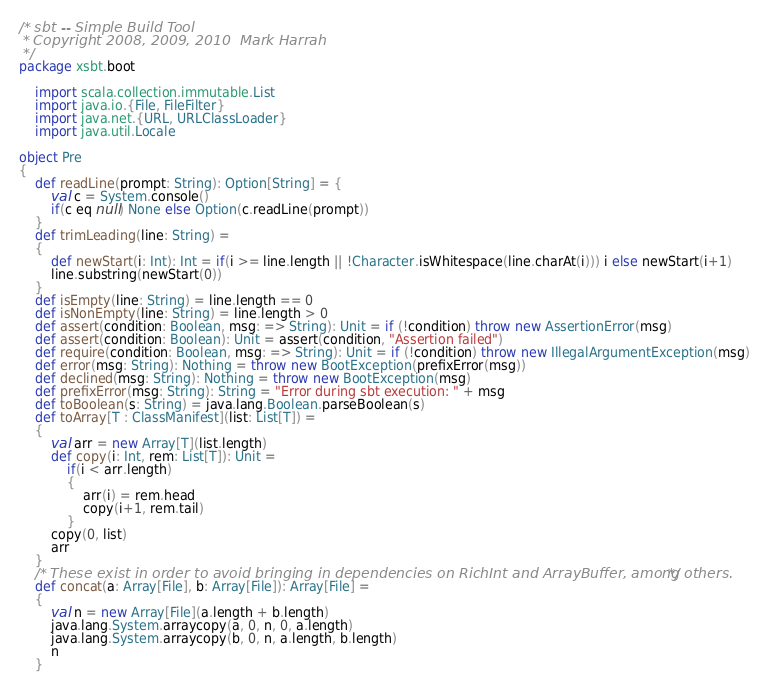Convert code to text. <code><loc_0><loc_0><loc_500><loc_500><_Scala_>/* sbt -- Simple Build Tool
 * Copyright 2008, 2009, 2010  Mark Harrah
 */
package xsbt.boot

	import scala.collection.immutable.List
	import java.io.{File, FileFilter}
	import java.net.{URL, URLClassLoader}
	import java.util.Locale

object Pre
{
	def readLine(prompt: String): Option[String] = {
		val c = System.console()
		if(c eq null) None else Option(c.readLine(prompt))
	}
	def trimLeading(line: String) =
	{
		def newStart(i: Int): Int = if(i >= line.length || !Character.isWhitespace(line.charAt(i))) i else newStart(i+1)
		line.substring(newStart(0))
	}
	def isEmpty(line: String) = line.length == 0
	def isNonEmpty(line: String) = line.length > 0
	def assert(condition: Boolean, msg: => String): Unit = if (!condition) throw new AssertionError(msg)
	def assert(condition: Boolean): Unit = assert(condition, "Assertion failed")
	def require(condition: Boolean, msg: => String): Unit = if (!condition) throw new IllegalArgumentException(msg)
	def error(msg: String): Nothing = throw new BootException(prefixError(msg))
	def declined(msg: String): Nothing = throw new BootException(msg)
	def prefixError(msg: String): String = "Error during sbt execution: " + msg
	def toBoolean(s: String) = java.lang.Boolean.parseBoolean(s)
	def toArray[T : ClassManifest](list: List[T]) =
	{
		val arr = new Array[T](list.length)
		def copy(i: Int, rem: List[T]): Unit =
			if(i < arr.length)
			{
				arr(i) = rem.head
				copy(i+1, rem.tail)
			}
		copy(0, list)
		arr
	}
	/* These exist in order to avoid bringing in dependencies on RichInt and ArrayBuffer, among others. */
	def concat(a: Array[File], b: Array[File]): Array[File] =
	{
		val n = new Array[File](a.length + b.length)
		java.lang.System.arraycopy(a, 0, n, 0, a.length)
		java.lang.System.arraycopy(b, 0, n, a.length, b.length)
		n
	}</code> 